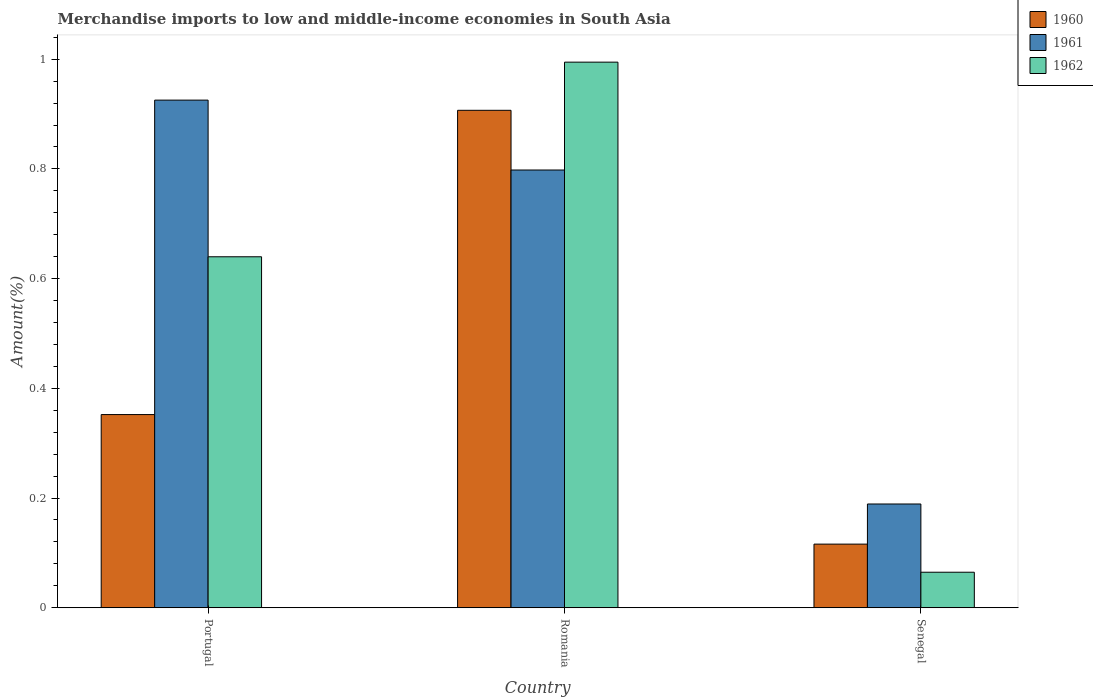How many different coloured bars are there?
Your response must be concise. 3. How many groups of bars are there?
Provide a succinct answer. 3. Are the number of bars per tick equal to the number of legend labels?
Your answer should be compact. Yes. How many bars are there on the 2nd tick from the left?
Provide a short and direct response. 3. What is the label of the 3rd group of bars from the left?
Give a very brief answer. Senegal. What is the percentage of amount earned from merchandise imports in 1962 in Romania?
Ensure brevity in your answer.  0.99. Across all countries, what is the maximum percentage of amount earned from merchandise imports in 1962?
Provide a succinct answer. 0.99. Across all countries, what is the minimum percentage of amount earned from merchandise imports in 1961?
Keep it short and to the point. 0.19. In which country was the percentage of amount earned from merchandise imports in 1962 maximum?
Keep it short and to the point. Romania. In which country was the percentage of amount earned from merchandise imports in 1962 minimum?
Give a very brief answer. Senegal. What is the total percentage of amount earned from merchandise imports in 1960 in the graph?
Provide a succinct answer. 1.37. What is the difference between the percentage of amount earned from merchandise imports in 1960 in Portugal and that in Senegal?
Your response must be concise. 0.24. What is the difference between the percentage of amount earned from merchandise imports in 1961 in Portugal and the percentage of amount earned from merchandise imports in 1960 in Romania?
Offer a very short reply. 0.02. What is the average percentage of amount earned from merchandise imports in 1961 per country?
Offer a very short reply. 0.64. What is the difference between the percentage of amount earned from merchandise imports of/in 1960 and percentage of amount earned from merchandise imports of/in 1962 in Portugal?
Offer a very short reply. -0.29. What is the ratio of the percentage of amount earned from merchandise imports in 1960 in Portugal to that in Romania?
Your answer should be very brief. 0.39. What is the difference between the highest and the second highest percentage of amount earned from merchandise imports in 1960?
Provide a succinct answer. 0.79. What is the difference between the highest and the lowest percentage of amount earned from merchandise imports in 1961?
Give a very brief answer. 0.74. Is the sum of the percentage of amount earned from merchandise imports in 1962 in Romania and Senegal greater than the maximum percentage of amount earned from merchandise imports in 1960 across all countries?
Offer a terse response. Yes. What does the 1st bar from the right in Portugal represents?
Make the answer very short. 1962. Is it the case that in every country, the sum of the percentage of amount earned from merchandise imports in 1961 and percentage of amount earned from merchandise imports in 1962 is greater than the percentage of amount earned from merchandise imports in 1960?
Your answer should be very brief. Yes. Are all the bars in the graph horizontal?
Keep it short and to the point. No. How many countries are there in the graph?
Ensure brevity in your answer.  3. Does the graph contain any zero values?
Your answer should be compact. No. Does the graph contain grids?
Give a very brief answer. No. How many legend labels are there?
Give a very brief answer. 3. How are the legend labels stacked?
Your answer should be compact. Vertical. What is the title of the graph?
Your answer should be compact. Merchandise imports to low and middle-income economies in South Asia. Does "1972" appear as one of the legend labels in the graph?
Provide a short and direct response. No. What is the label or title of the Y-axis?
Your answer should be very brief. Amount(%). What is the Amount(%) of 1960 in Portugal?
Offer a very short reply. 0.35. What is the Amount(%) in 1961 in Portugal?
Your answer should be compact. 0.93. What is the Amount(%) of 1962 in Portugal?
Provide a short and direct response. 0.64. What is the Amount(%) of 1960 in Romania?
Offer a very short reply. 0.91. What is the Amount(%) of 1961 in Romania?
Make the answer very short. 0.8. What is the Amount(%) in 1962 in Romania?
Ensure brevity in your answer.  0.99. What is the Amount(%) in 1960 in Senegal?
Offer a very short reply. 0.12. What is the Amount(%) of 1961 in Senegal?
Provide a succinct answer. 0.19. What is the Amount(%) of 1962 in Senegal?
Your response must be concise. 0.06. Across all countries, what is the maximum Amount(%) of 1960?
Offer a very short reply. 0.91. Across all countries, what is the maximum Amount(%) in 1961?
Give a very brief answer. 0.93. Across all countries, what is the maximum Amount(%) of 1962?
Give a very brief answer. 0.99. Across all countries, what is the minimum Amount(%) in 1960?
Offer a terse response. 0.12. Across all countries, what is the minimum Amount(%) in 1961?
Offer a very short reply. 0.19. Across all countries, what is the minimum Amount(%) in 1962?
Offer a very short reply. 0.06. What is the total Amount(%) in 1960 in the graph?
Offer a very short reply. 1.38. What is the total Amount(%) of 1961 in the graph?
Offer a very short reply. 1.91. What is the total Amount(%) in 1962 in the graph?
Offer a terse response. 1.7. What is the difference between the Amount(%) in 1960 in Portugal and that in Romania?
Keep it short and to the point. -0.55. What is the difference between the Amount(%) of 1961 in Portugal and that in Romania?
Offer a very short reply. 0.13. What is the difference between the Amount(%) of 1962 in Portugal and that in Romania?
Make the answer very short. -0.35. What is the difference between the Amount(%) of 1960 in Portugal and that in Senegal?
Provide a short and direct response. 0.24. What is the difference between the Amount(%) in 1961 in Portugal and that in Senegal?
Offer a very short reply. 0.74. What is the difference between the Amount(%) of 1962 in Portugal and that in Senegal?
Your response must be concise. 0.57. What is the difference between the Amount(%) in 1960 in Romania and that in Senegal?
Provide a succinct answer. 0.79. What is the difference between the Amount(%) of 1961 in Romania and that in Senegal?
Your answer should be compact. 0.61. What is the difference between the Amount(%) of 1962 in Romania and that in Senegal?
Ensure brevity in your answer.  0.93. What is the difference between the Amount(%) of 1960 in Portugal and the Amount(%) of 1961 in Romania?
Make the answer very short. -0.45. What is the difference between the Amount(%) in 1960 in Portugal and the Amount(%) in 1962 in Romania?
Your answer should be very brief. -0.64. What is the difference between the Amount(%) of 1961 in Portugal and the Amount(%) of 1962 in Romania?
Your response must be concise. -0.07. What is the difference between the Amount(%) of 1960 in Portugal and the Amount(%) of 1961 in Senegal?
Make the answer very short. 0.16. What is the difference between the Amount(%) of 1960 in Portugal and the Amount(%) of 1962 in Senegal?
Make the answer very short. 0.29. What is the difference between the Amount(%) of 1961 in Portugal and the Amount(%) of 1962 in Senegal?
Your response must be concise. 0.86. What is the difference between the Amount(%) in 1960 in Romania and the Amount(%) in 1961 in Senegal?
Your answer should be compact. 0.72. What is the difference between the Amount(%) of 1960 in Romania and the Amount(%) of 1962 in Senegal?
Your answer should be very brief. 0.84. What is the difference between the Amount(%) in 1961 in Romania and the Amount(%) in 1962 in Senegal?
Your response must be concise. 0.73. What is the average Amount(%) in 1960 per country?
Give a very brief answer. 0.46. What is the average Amount(%) in 1961 per country?
Your response must be concise. 0.64. What is the average Amount(%) in 1962 per country?
Offer a terse response. 0.57. What is the difference between the Amount(%) of 1960 and Amount(%) of 1961 in Portugal?
Give a very brief answer. -0.57. What is the difference between the Amount(%) of 1960 and Amount(%) of 1962 in Portugal?
Ensure brevity in your answer.  -0.29. What is the difference between the Amount(%) of 1961 and Amount(%) of 1962 in Portugal?
Offer a terse response. 0.29. What is the difference between the Amount(%) of 1960 and Amount(%) of 1961 in Romania?
Provide a short and direct response. 0.11. What is the difference between the Amount(%) in 1960 and Amount(%) in 1962 in Romania?
Provide a short and direct response. -0.09. What is the difference between the Amount(%) in 1961 and Amount(%) in 1962 in Romania?
Provide a succinct answer. -0.2. What is the difference between the Amount(%) in 1960 and Amount(%) in 1961 in Senegal?
Ensure brevity in your answer.  -0.07. What is the difference between the Amount(%) of 1960 and Amount(%) of 1962 in Senegal?
Make the answer very short. 0.05. What is the difference between the Amount(%) of 1961 and Amount(%) of 1962 in Senegal?
Your answer should be compact. 0.12. What is the ratio of the Amount(%) in 1960 in Portugal to that in Romania?
Offer a terse response. 0.39. What is the ratio of the Amount(%) in 1961 in Portugal to that in Romania?
Make the answer very short. 1.16. What is the ratio of the Amount(%) of 1962 in Portugal to that in Romania?
Provide a succinct answer. 0.64. What is the ratio of the Amount(%) in 1960 in Portugal to that in Senegal?
Keep it short and to the point. 3.04. What is the ratio of the Amount(%) of 1961 in Portugal to that in Senegal?
Your response must be concise. 4.89. What is the ratio of the Amount(%) in 1962 in Portugal to that in Senegal?
Keep it short and to the point. 9.88. What is the ratio of the Amount(%) in 1960 in Romania to that in Senegal?
Make the answer very short. 7.82. What is the ratio of the Amount(%) of 1961 in Romania to that in Senegal?
Your response must be concise. 4.22. What is the ratio of the Amount(%) of 1962 in Romania to that in Senegal?
Ensure brevity in your answer.  15.36. What is the difference between the highest and the second highest Amount(%) of 1960?
Make the answer very short. 0.55. What is the difference between the highest and the second highest Amount(%) of 1961?
Your answer should be very brief. 0.13. What is the difference between the highest and the second highest Amount(%) in 1962?
Provide a short and direct response. 0.35. What is the difference between the highest and the lowest Amount(%) in 1960?
Offer a terse response. 0.79. What is the difference between the highest and the lowest Amount(%) in 1961?
Offer a terse response. 0.74. What is the difference between the highest and the lowest Amount(%) of 1962?
Offer a terse response. 0.93. 